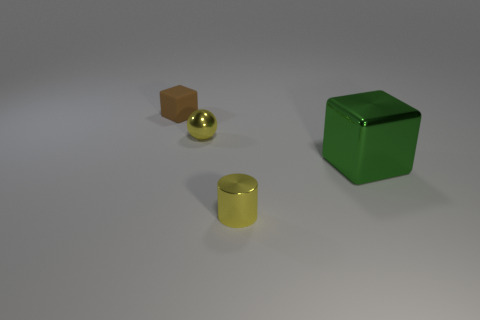Add 3 small rubber objects. How many objects exist? 7 Subtract all spheres. How many objects are left? 3 Subtract 1 yellow balls. How many objects are left? 3 Subtract all yellow blocks. Subtract all red cylinders. How many blocks are left? 2 Subtract all balls. Subtract all large cyan rubber balls. How many objects are left? 3 Add 4 spheres. How many spheres are left? 5 Add 1 small metallic cylinders. How many small metallic cylinders exist? 2 